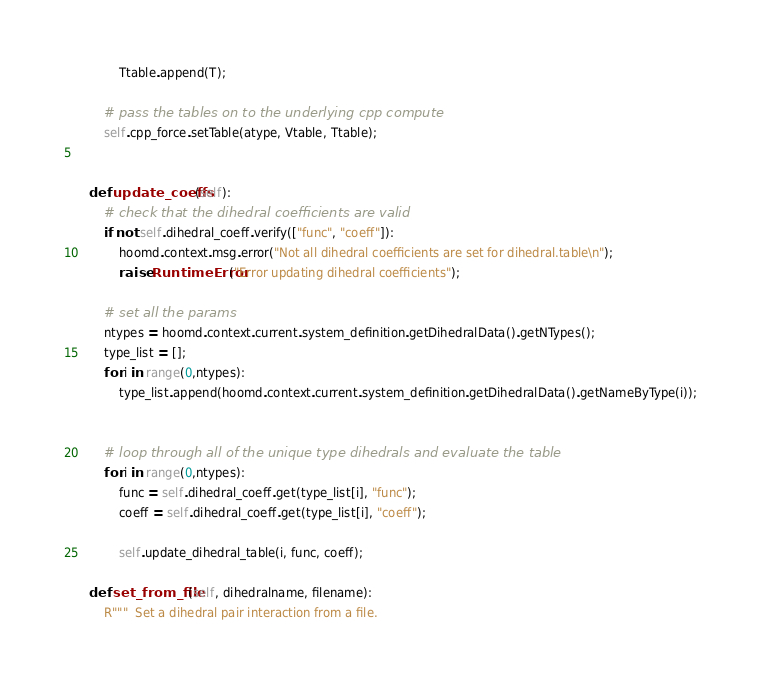<code> <loc_0><loc_0><loc_500><loc_500><_Python_>            Ttable.append(T);

        # pass the tables on to the underlying cpp compute
        self.cpp_force.setTable(atype, Vtable, Ttable);


    def update_coeffs(self):
        # check that the dihedral coefficients are valid
        if not self.dihedral_coeff.verify(["func", "coeff"]):
            hoomd.context.msg.error("Not all dihedral coefficients are set for dihedral.table\n");
            raise RuntimeError("Error updating dihedral coefficients");

        # set all the params
        ntypes = hoomd.context.current.system_definition.getDihedralData().getNTypes();
        type_list = [];
        for i in range(0,ntypes):
            type_list.append(hoomd.context.current.system_definition.getDihedralData().getNameByType(i));


        # loop through all of the unique type dihedrals and evaluate the table
        for i in range(0,ntypes):
            func = self.dihedral_coeff.get(type_list[i], "func");
            coeff = self.dihedral_coeff.get(type_list[i], "coeff");

            self.update_dihedral_table(i, func, coeff);

    def set_from_file(self, dihedralname, filename):
        R"""  Set a dihedral pair interaction from a file.
</code> 